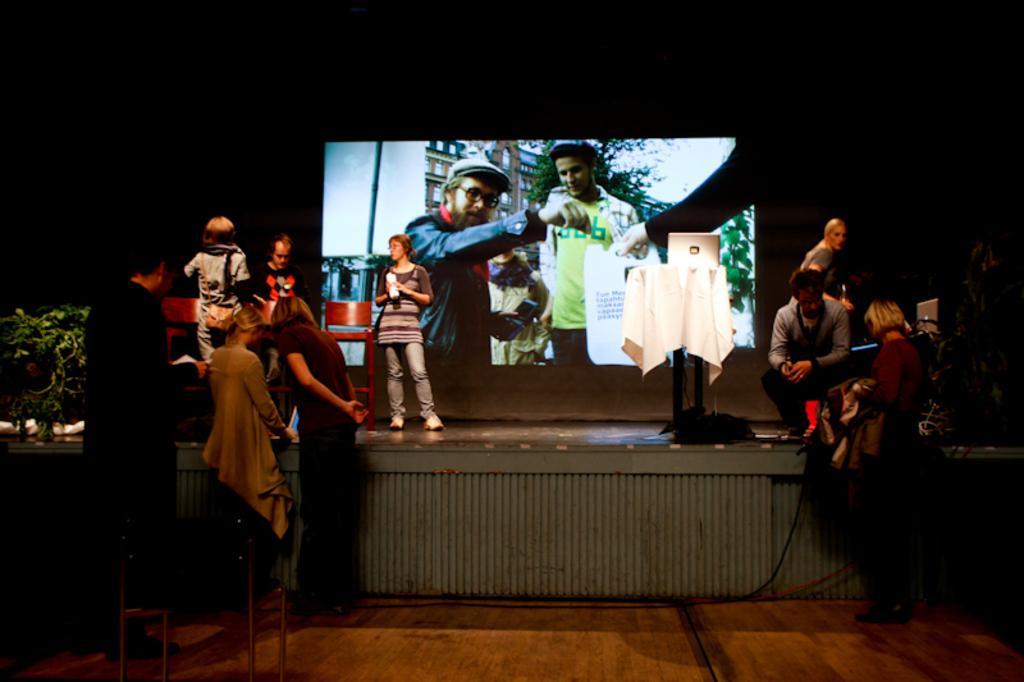Can you describe this image briefly? In this image we can see people. There is a podium and we can see a laptop placed on the podium. On the left there is a houseplant. At the bottom there is a chair. In the background there is a screen. 